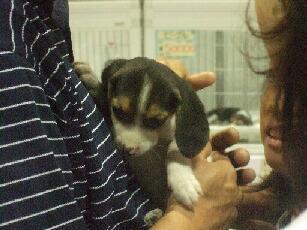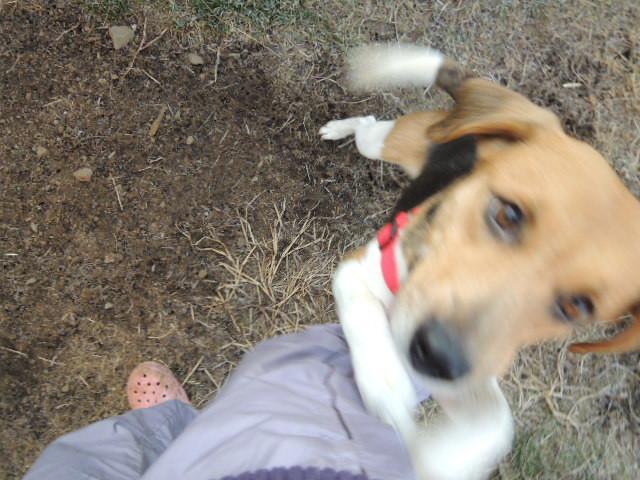The first image is the image on the left, the second image is the image on the right. Assess this claim about the two images: "All dogs' stomachs are visible.". Correct or not? Answer yes or no. No. 